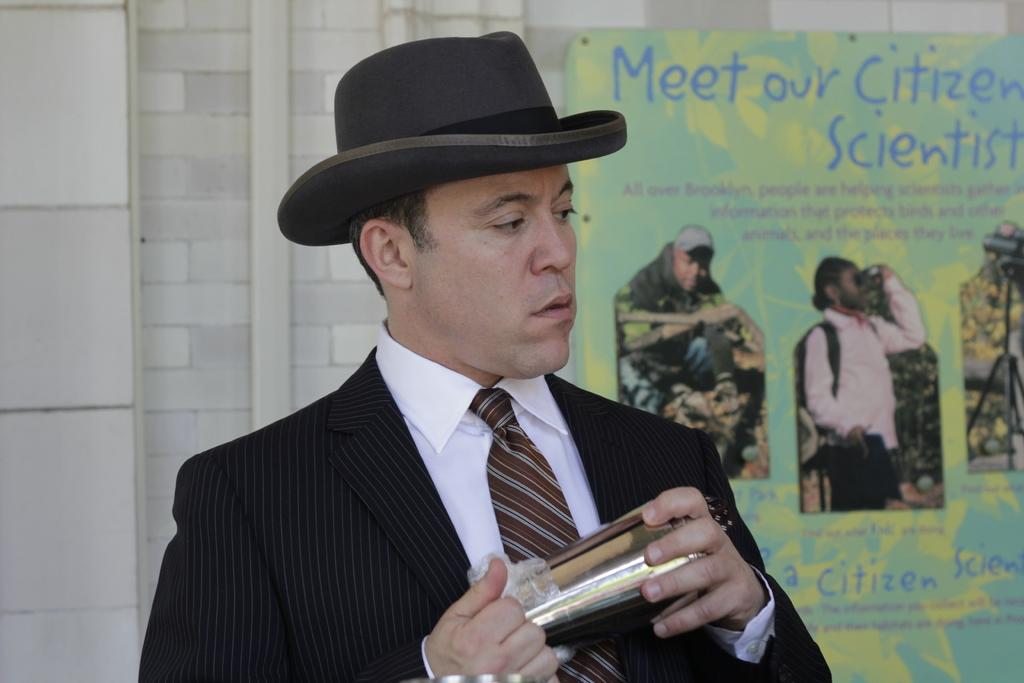Who or what is the main subject in the center of the image? There is a person in the center of the image. What is the person wearing on their head? The person is wearing a hat. What can be seen in the background of the image? There is a poster and a wall in the background of the image. What type of mint is growing on the wall in the image? There is no mint visible in the image; the wall is part of the background and does not have any plants growing on it. 